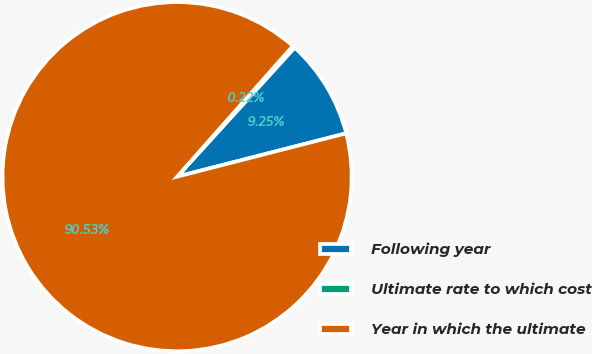Convert chart to OTSL. <chart><loc_0><loc_0><loc_500><loc_500><pie_chart><fcel>Following year<fcel>Ultimate rate to which cost<fcel>Year in which the ultimate<nl><fcel>9.25%<fcel>0.22%<fcel>90.52%<nl></chart> 